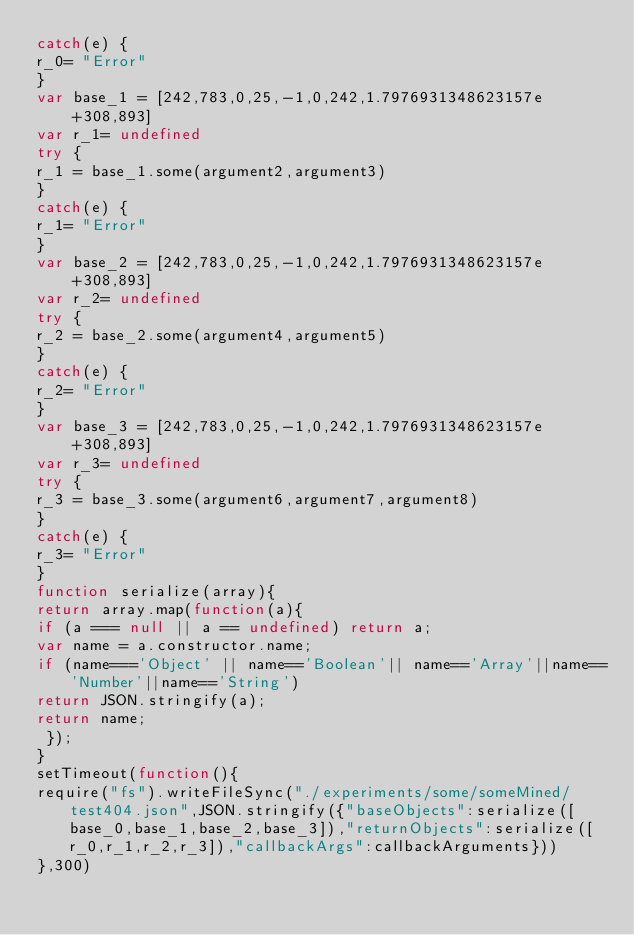Convert code to text. <code><loc_0><loc_0><loc_500><loc_500><_JavaScript_>catch(e) {
r_0= "Error"
}
var base_1 = [242,783,0,25,-1,0,242,1.7976931348623157e+308,893]
var r_1= undefined
try {
r_1 = base_1.some(argument2,argument3)
}
catch(e) {
r_1= "Error"
}
var base_2 = [242,783,0,25,-1,0,242,1.7976931348623157e+308,893]
var r_2= undefined
try {
r_2 = base_2.some(argument4,argument5)
}
catch(e) {
r_2= "Error"
}
var base_3 = [242,783,0,25,-1,0,242,1.7976931348623157e+308,893]
var r_3= undefined
try {
r_3 = base_3.some(argument6,argument7,argument8)
}
catch(e) {
r_3= "Error"
}
function serialize(array){
return array.map(function(a){
if (a === null || a == undefined) return a;
var name = a.constructor.name;
if (name==='Object' || name=='Boolean'|| name=='Array'||name=='Number'||name=='String')
return JSON.stringify(a);
return name;
 });
}
setTimeout(function(){
require("fs").writeFileSync("./experiments/some/someMined/test404.json",JSON.stringify({"baseObjects":serialize([base_0,base_1,base_2,base_3]),"returnObjects":serialize([r_0,r_1,r_2,r_3]),"callbackArgs":callbackArguments}))
},300)</code> 